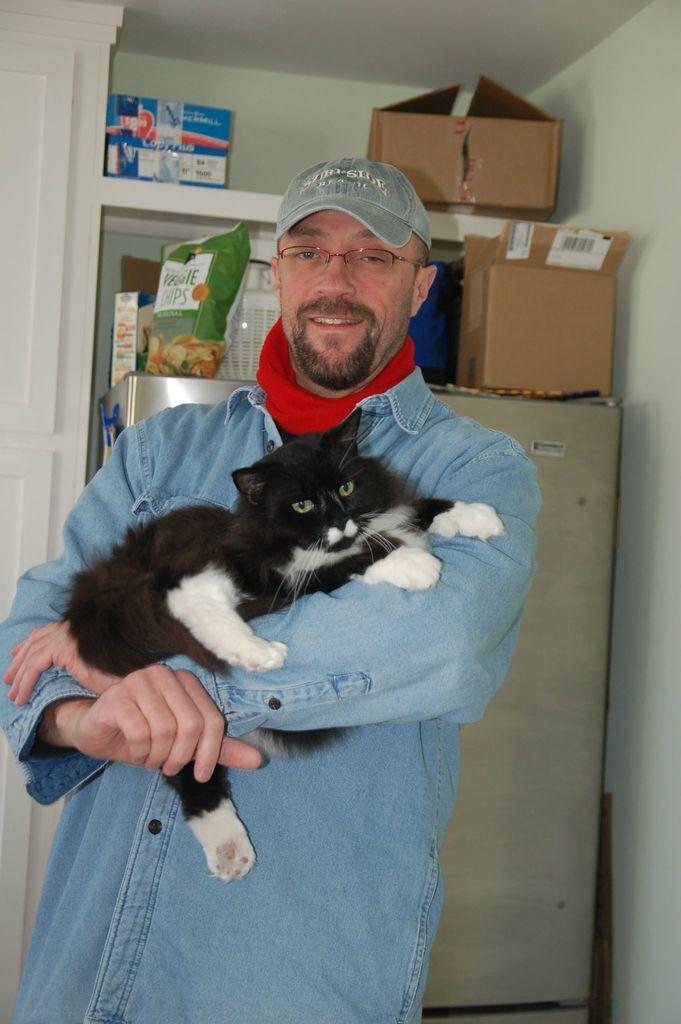Describe this image in one or two sentences. In this image, we can see a man standing and he is holding a black color cat, he is wearing a hat, in the background we can see two carton boxes. 